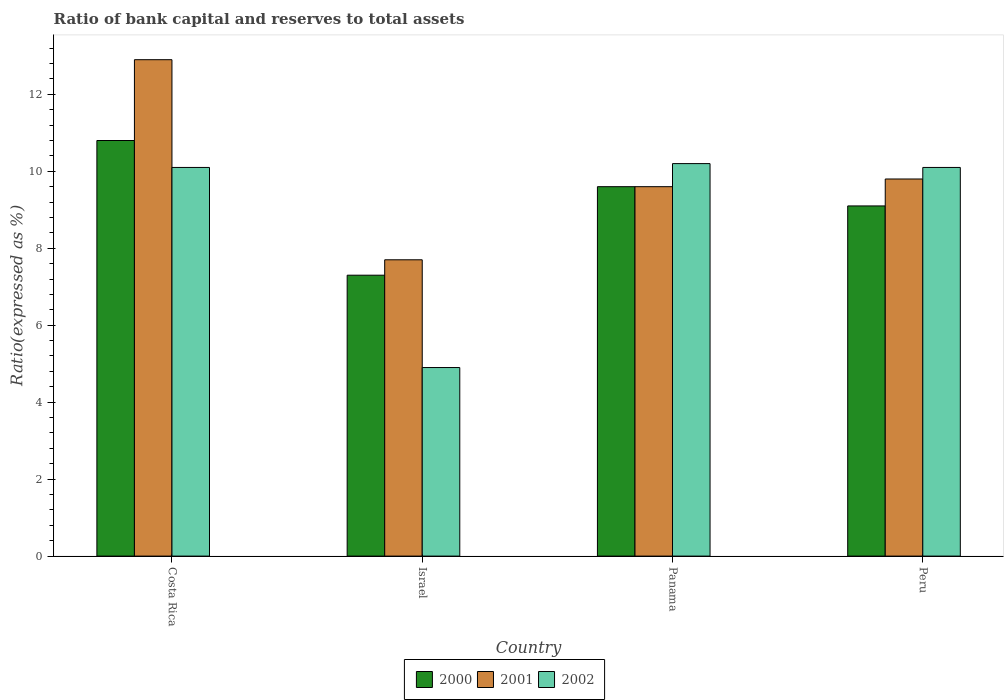How many different coloured bars are there?
Ensure brevity in your answer.  3. How many groups of bars are there?
Keep it short and to the point. 4. How many bars are there on the 1st tick from the left?
Make the answer very short. 3. How many bars are there on the 2nd tick from the right?
Make the answer very short. 3. What is the label of the 4th group of bars from the left?
Make the answer very short. Peru. In how many cases, is the number of bars for a given country not equal to the number of legend labels?
Your response must be concise. 0. What is the ratio of bank capital and reserves to total assets in 2002 in Israel?
Provide a succinct answer. 4.9. Across all countries, what is the minimum ratio of bank capital and reserves to total assets in 2001?
Your answer should be compact. 7.7. In which country was the ratio of bank capital and reserves to total assets in 2002 minimum?
Your response must be concise. Israel. What is the difference between the ratio of bank capital and reserves to total assets in 2001 in Costa Rica and that in Peru?
Give a very brief answer. 3.1. What is the difference between the ratio of bank capital and reserves to total assets in 2000 in Peru and the ratio of bank capital and reserves to total assets in 2001 in Panama?
Offer a very short reply. -0.5. What is the average ratio of bank capital and reserves to total assets in 2000 per country?
Offer a very short reply. 9.2. What is the difference between the ratio of bank capital and reserves to total assets of/in 2002 and ratio of bank capital and reserves to total assets of/in 2000 in Costa Rica?
Provide a short and direct response. -0.7. What is the difference between the highest and the second highest ratio of bank capital and reserves to total assets in 2001?
Offer a terse response. -3.1. What is the difference between the highest and the lowest ratio of bank capital and reserves to total assets in 2001?
Your response must be concise. 5.2. In how many countries, is the ratio of bank capital and reserves to total assets in 2000 greater than the average ratio of bank capital and reserves to total assets in 2000 taken over all countries?
Your response must be concise. 2. Is the sum of the ratio of bank capital and reserves to total assets in 2002 in Costa Rica and Peru greater than the maximum ratio of bank capital and reserves to total assets in 2001 across all countries?
Your response must be concise. Yes. What does the 3rd bar from the right in Israel represents?
Ensure brevity in your answer.  2000. Are all the bars in the graph horizontal?
Ensure brevity in your answer.  No. Does the graph contain grids?
Your answer should be compact. No. How many legend labels are there?
Provide a succinct answer. 3. How are the legend labels stacked?
Your answer should be very brief. Horizontal. What is the title of the graph?
Offer a terse response. Ratio of bank capital and reserves to total assets. What is the label or title of the Y-axis?
Give a very brief answer. Ratio(expressed as %). What is the Ratio(expressed as %) in 2000 in Costa Rica?
Ensure brevity in your answer.  10.8. What is the Ratio(expressed as %) of 2002 in Costa Rica?
Offer a very short reply. 10.1. What is the Ratio(expressed as %) of 2002 in Panama?
Give a very brief answer. 10.2. Across all countries, what is the maximum Ratio(expressed as %) of 2000?
Keep it short and to the point. 10.8. Across all countries, what is the maximum Ratio(expressed as %) in 2001?
Your answer should be very brief. 12.9. Across all countries, what is the minimum Ratio(expressed as %) in 2001?
Your answer should be very brief. 7.7. Across all countries, what is the minimum Ratio(expressed as %) in 2002?
Your answer should be compact. 4.9. What is the total Ratio(expressed as %) in 2000 in the graph?
Offer a very short reply. 36.8. What is the total Ratio(expressed as %) in 2001 in the graph?
Your answer should be very brief. 40. What is the total Ratio(expressed as %) of 2002 in the graph?
Provide a short and direct response. 35.3. What is the difference between the Ratio(expressed as %) in 2001 in Costa Rica and that in Panama?
Offer a very short reply. 3.3. What is the difference between the Ratio(expressed as %) in 2000 in Costa Rica and that in Peru?
Offer a terse response. 1.7. What is the difference between the Ratio(expressed as %) of 2001 in Costa Rica and that in Peru?
Offer a terse response. 3.1. What is the difference between the Ratio(expressed as %) in 2002 in Costa Rica and that in Peru?
Your answer should be very brief. 0. What is the difference between the Ratio(expressed as %) in 2002 in Israel and that in Panama?
Your response must be concise. -5.3. What is the difference between the Ratio(expressed as %) in 2001 in Panama and that in Peru?
Provide a short and direct response. -0.2. What is the difference between the Ratio(expressed as %) in 2002 in Panama and that in Peru?
Your answer should be compact. 0.1. What is the difference between the Ratio(expressed as %) in 2000 in Costa Rica and the Ratio(expressed as %) in 2002 in Israel?
Provide a short and direct response. 5.9. What is the difference between the Ratio(expressed as %) in 2001 in Costa Rica and the Ratio(expressed as %) in 2002 in Israel?
Your response must be concise. 8. What is the difference between the Ratio(expressed as %) in 2000 in Costa Rica and the Ratio(expressed as %) in 2001 in Peru?
Offer a terse response. 1. What is the difference between the Ratio(expressed as %) of 2001 in Costa Rica and the Ratio(expressed as %) of 2002 in Peru?
Your answer should be compact. 2.8. What is the difference between the Ratio(expressed as %) of 2000 in Israel and the Ratio(expressed as %) of 2001 in Panama?
Your answer should be compact. -2.3. What is the difference between the Ratio(expressed as %) in 2000 in Israel and the Ratio(expressed as %) in 2002 in Panama?
Offer a very short reply. -2.9. What is the difference between the Ratio(expressed as %) of 2001 in Israel and the Ratio(expressed as %) of 2002 in Panama?
Your response must be concise. -2.5. What is the average Ratio(expressed as %) in 2000 per country?
Keep it short and to the point. 9.2. What is the average Ratio(expressed as %) in 2002 per country?
Your answer should be very brief. 8.82. What is the difference between the Ratio(expressed as %) of 2001 and Ratio(expressed as %) of 2002 in Costa Rica?
Make the answer very short. 2.8. What is the difference between the Ratio(expressed as %) in 2000 and Ratio(expressed as %) in 2002 in Israel?
Offer a very short reply. 2.4. What is the difference between the Ratio(expressed as %) in 2001 and Ratio(expressed as %) in 2002 in Israel?
Offer a terse response. 2.8. What is the difference between the Ratio(expressed as %) of 2000 and Ratio(expressed as %) of 2001 in Panama?
Keep it short and to the point. 0. What is the difference between the Ratio(expressed as %) of 2000 and Ratio(expressed as %) of 2002 in Panama?
Make the answer very short. -0.6. What is the difference between the Ratio(expressed as %) of 2001 and Ratio(expressed as %) of 2002 in Panama?
Offer a terse response. -0.6. What is the difference between the Ratio(expressed as %) of 2000 and Ratio(expressed as %) of 2001 in Peru?
Ensure brevity in your answer.  -0.7. What is the ratio of the Ratio(expressed as %) of 2000 in Costa Rica to that in Israel?
Your answer should be compact. 1.48. What is the ratio of the Ratio(expressed as %) in 2001 in Costa Rica to that in Israel?
Ensure brevity in your answer.  1.68. What is the ratio of the Ratio(expressed as %) of 2002 in Costa Rica to that in Israel?
Your answer should be compact. 2.06. What is the ratio of the Ratio(expressed as %) of 2000 in Costa Rica to that in Panama?
Offer a very short reply. 1.12. What is the ratio of the Ratio(expressed as %) of 2001 in Costa Rica to that in Panama?
Provide a succinct answer. 1.34. What is the ratio of the Ratio(expressed as %) in 2002 in Costa Rica to that in Panama?
Offer a very short reply. 0.99. What is the ratio of the Ratio(expressed as %) in 2000 in Costa Rica to that in Peru?
Your answer should be very brief. 1.19. What is the ratio of the Ratio(expressed as %) in 2001 in Costa Rica to that in Peru?
Keep it short and to the point. 1.32. What is the ratio of the Ratio(expressed as %) in 2000 in Israel to that in Panama?
Offer a terse response. 0.76. What is the ratio of the Ratio(expressed as %) in 2001 in Israel to that in Panama?
Ensure brevity in your answer.  0.8. What is the ratio of the Ratio(expressed as %) of 2002 in Israel to that in Panama?
Make the answer very short. 0.48. What is the ratio of the Ratio(expressed as %) of 2000 in Israel to that in Peru?
Your answer should be compact. 0.8. What is the ratio of the Ratio(expressed as %) in 2001 in Israel to that in Peru?
Provide a short and direct response. 0.79. What is the ratio of the Ratio(expressed as %) in 2002 in Israel to that in Peru?
Provide a succinct answer. 0.49. What is the ratio of the Ratio(expressed as %) in 2000 in Panama to that in Peru?
Make the answer very short. 1.05. What is the ratio of the Ratio(expressed as %) of 2001 in Panama to that in Peru?
Ensure brevity in your answer.  0.98. What is the ratio of the Ratio(expressed as %) in 2002 in Panama to that in Peru?
Your answer should be very brief. 1.01. What is the difference between the highest and the second highest Ratio(expressed as %) of 2000?
Ensure brevity in your answer.  1.2. What is the difference between the highest and the lowest Ratio(expressed as %) of 2001?
Offer a terse response. 5.2. 